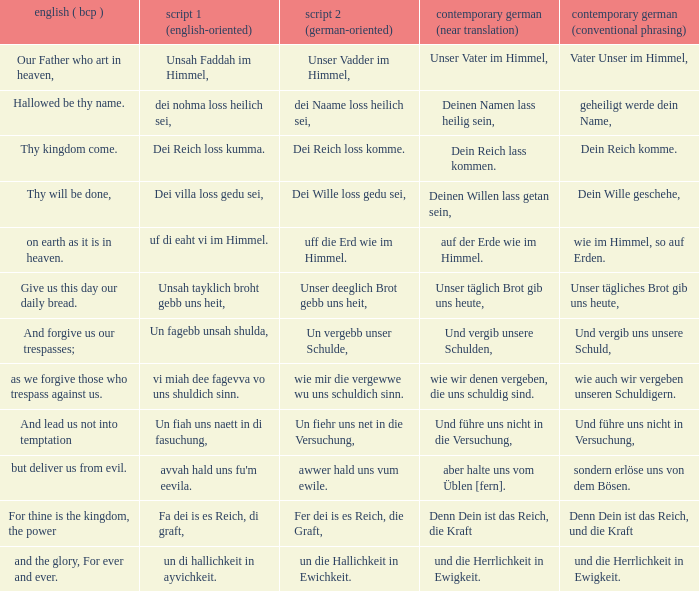What is the english (bcp) phrase "for thine is the kingdom, the power" in modern german with standard wording? Denn Dein ist das Reich, und die Kraft. 